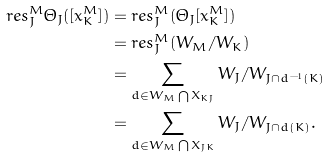Convert formula to latex. <formula><loc_0><loc_0><loc_500><loc_500>{ r e s _ { J } ^ { M } } { \Theta _ { J } } ( [ x _ { K } ^ { M } ] ) & = { r e s _ { J } ^ { M } } ( { \Theta _ { J } } [ x _ { K } ^ { M } ] ) \\ & = { r e s _ { J } ^ { M } } ( W _ { M } / W _ { K } ) \\ & = \sum _ { d \in { { W _ { M } } \bigcap { X _ { K J } } } } W _ { J } / W _ { J \cap { d ^ { - 1 } ( K ) } } \\ & = \sum _ { d \in { { W _ { M } } \bigcap { X _ { J K } } } } { W _ { J } / W _ { J \cap { d ( K ) } } } .</formula> 